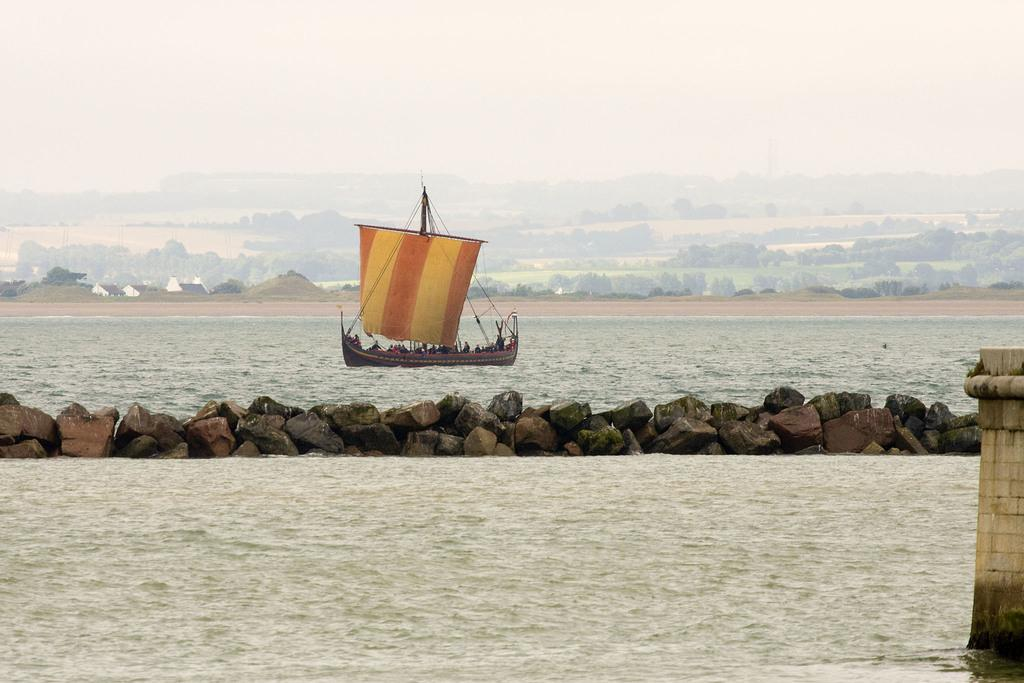What is present in the image that is not solid? There is water in the image. What type of structure can be seen in the image? There is a wall in the image. What type of natural formation is present in the image? There are rocks in the image. What mode of transportation is being used by the people in the image? There are people in a boat in the image. What type of vegetation can be seen in the background of the image? There are trees in the background of the image. What part of the natural environment is visible in the background of the image? The sky is visible in the background of the image. What type of story is being told by the people in the boat in the image? There is no indication in the image that the people in the boat are telling a story. How many accounts can be seen in the image? There are no accounts visible in the image. 